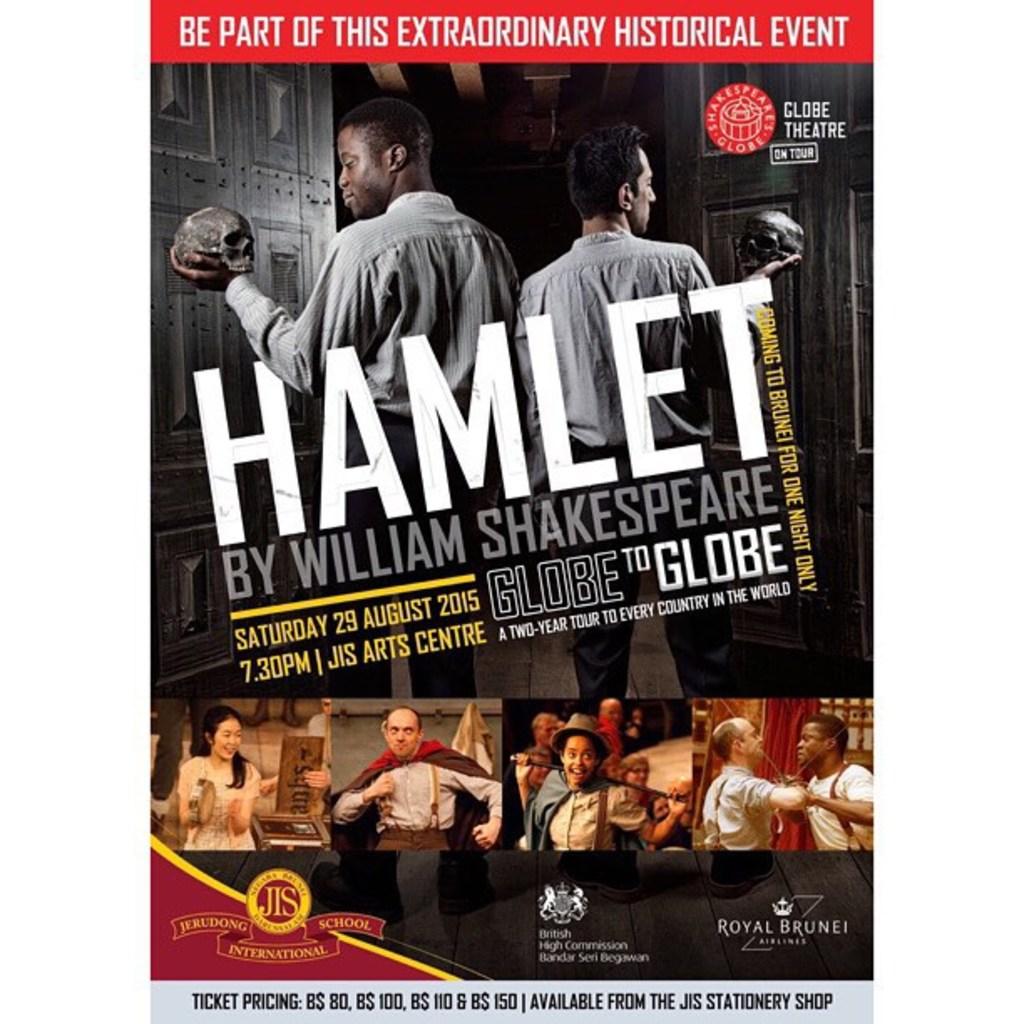What is the title of the play?
Offer a terse response. Hamlet. Who is the author of the book?
Provide a short and direct response. William shakespeare. 